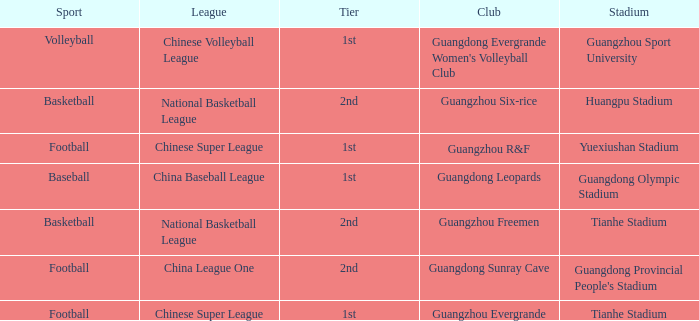Which tier is for football at Tianhe Stadium? 1st. Can you parse all the data within this table? {'header': ['Sport', 'League', 'Tier', 'Club', 'Stadium'], 'rows': [['Volleyball', 'Chinese Volleyball League', '1st', "Guangdong Evergrande Women's Volleyball Club", 'Guangzhou Sport University'], ['Basketball', 'National Basketball League', '2nd', 'Guangzhou Six-rice', 'Huangpu Stadium'], ['Football', 'Chinese Super League', '1st', 'Guangzhou R&F', 'Yuexiushan Stadium'], ['Baseball', 'China Baseball League', '1st', 'Guangdong Leopards', 'Guangdong Olympic Stadium'], ['Basketball', 'National Basketball League', '2nd', 'Guangzhou Freemen', 'Tianhe Stadium'], ['Football', 'China League One', '2nd', 'Guangdong Sunray Cave', "Guangdong Provincial People's Stadium"], ['Football', 'Chinese Super League', '1st', 'Guangzhou Evergrande', 'Tianhe Stadium']]} 